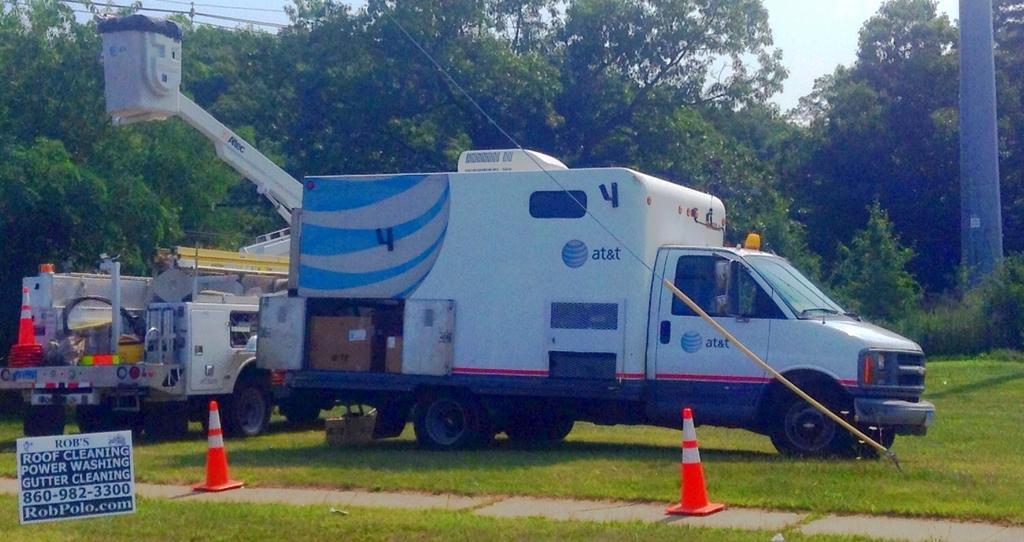How would you summarize this image in a sentence or two? In this image we can see two vehicle with some object on the grass, there are two orange and white color object on the floor and there is a board with some text an in the background there are few trees, a pole, wires and sky. 